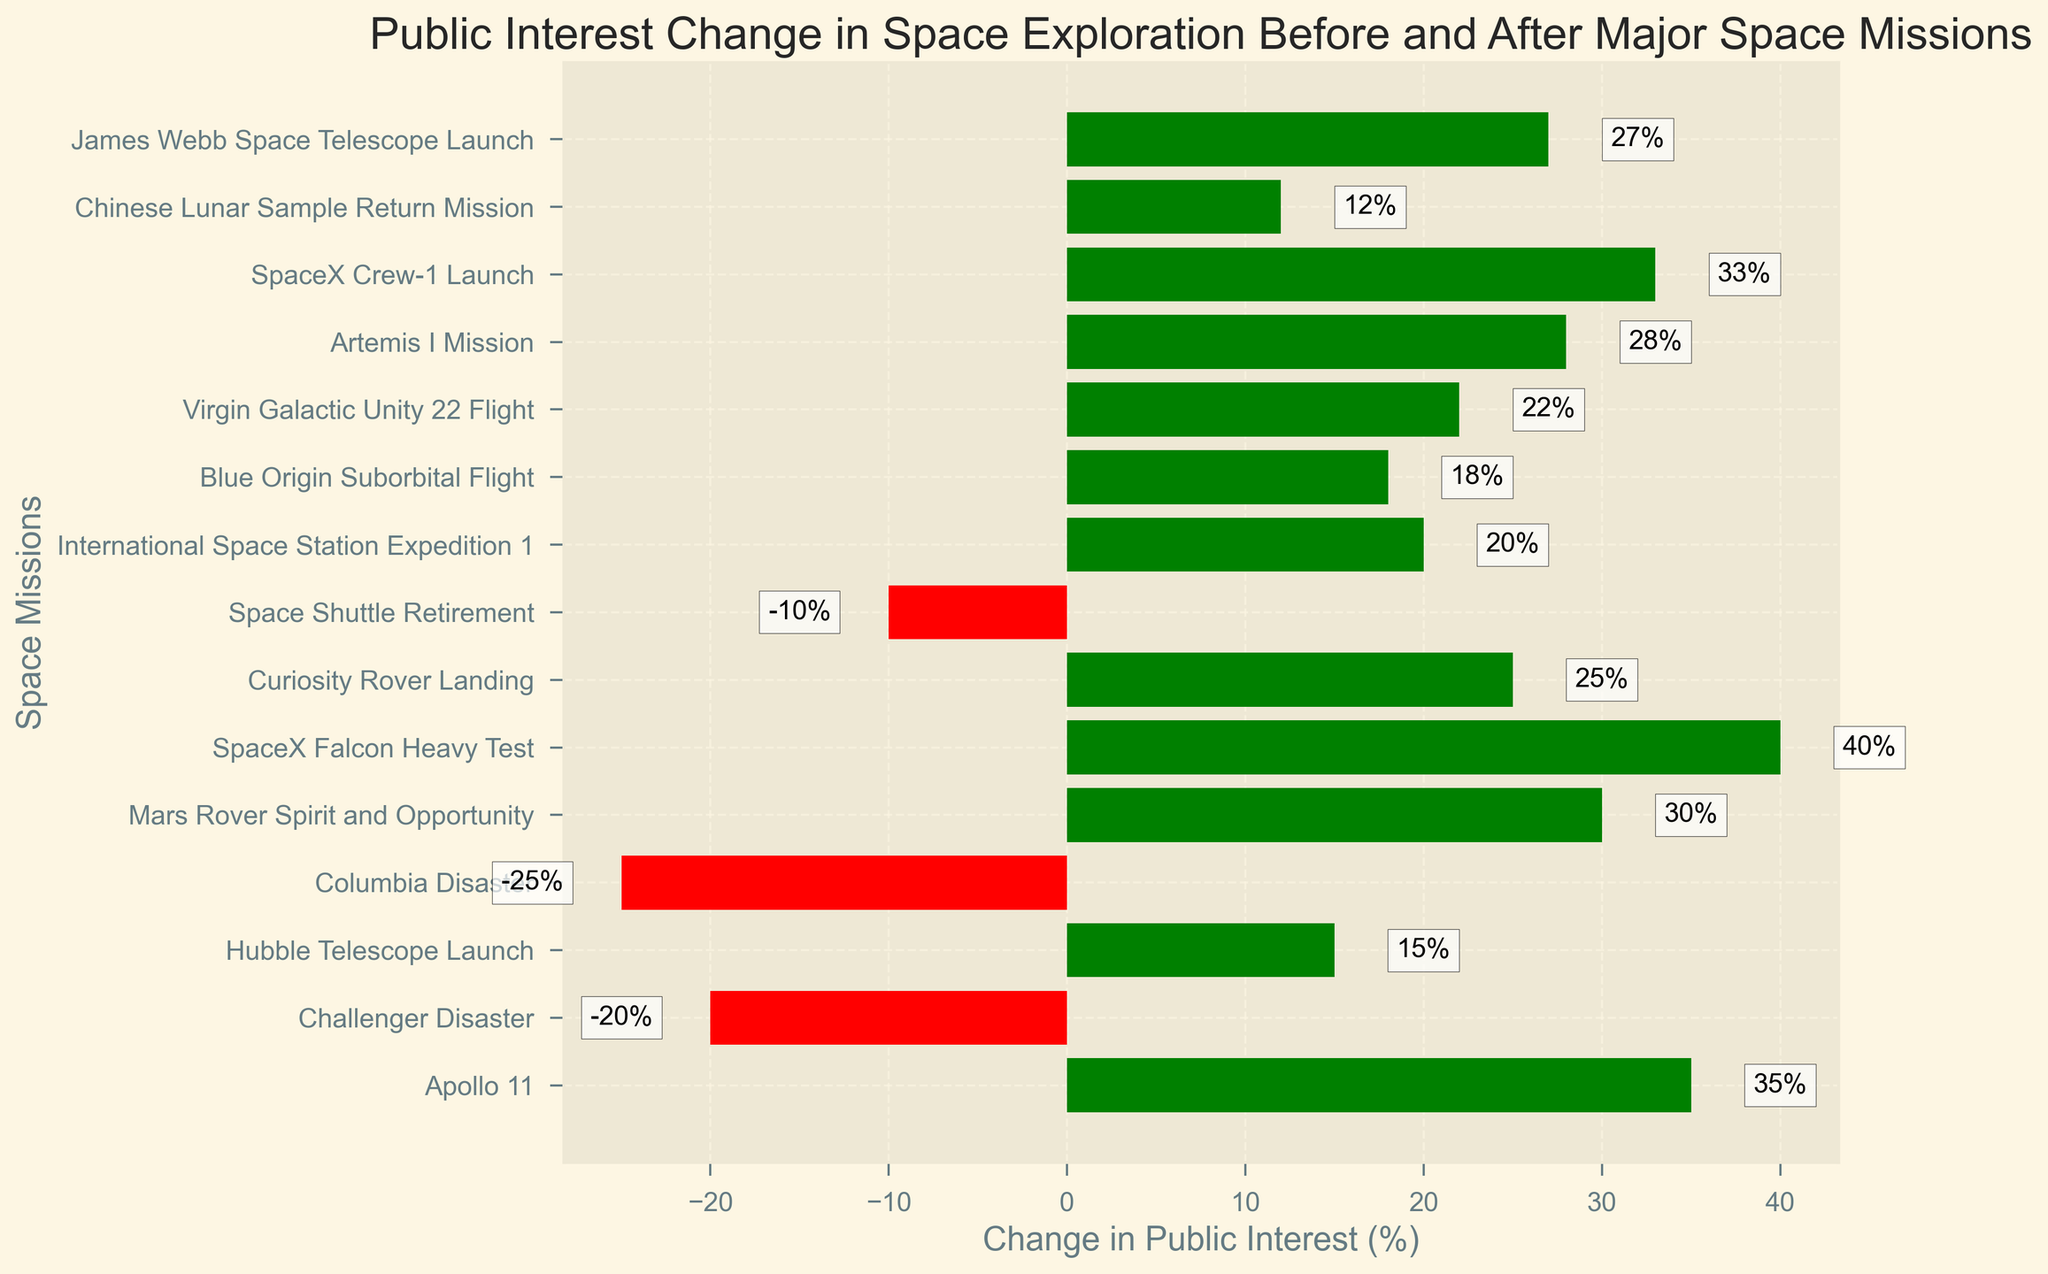Which space mission saw the greatest increase in public interest? Look at the mission with the longest green bar, which represents the greatest positive change in public interest.
Answer: SpaceX Falcon Heavy Test Which space mission saw the greatest decrease in public interest? Look at the mission with the longest red bar, which represents the greatest negative change in public interest.
Answer: Columbia Disaster How many missions resulted in a negative change in public interest? Count the number of bars that are red, indicating a negative change.
Answer: 3 What is the total change in public interest for all the missions combined? Sum the values of all the bars (positive and negative) to get the total change in public interest.
Answer: 270 Compare the public interest change in the Apollo 11 mission to the SpaceX Crew-1 Launch. Which had a higher increase? Compare the lengths of the green bars for Apollo 11 and SpaceX Crew-1 Launch. Apollo 11 is 35% and SpaceX Crew-1 Launch is 33%.
Answer: Apollo 11 What is the average change in public interest among the missions listed? Add up all the changes and divide by the number of missions to find the average. Total change is 270, and there are 15 missions, so the average is 270 / 15.
Answer: 18 How does the public interest change for the Challenger Disaster compare to the Space Shuttle Retirement? Compare the lengths of the red bars for both missions. Challenger Disaster is -20% and Space Shuttle Retirement is -10%.
Answer: Challenger Disaster is lower Which mission had a higher public interest change, the Curiosity Rover Landing or the Blue Origin Suborbital Flight? Compare the lengths of their green bars. Curiosity Rover Landing is 25% and Blue Origin Suborbital Flight is 18%.
Answer: Curiosity Rover Landing What is the median change in public interest for the listed missions? Arrange the changes in numerical order and find the middle value. The ordered changes are: -25, -20, -10, 12, 15, 18, 20, 22, 25, 27, 28, 30, 33, 35, 40. The median value is (20+22)/2.
Answer: 21 Which missions have a change in public interest less than zero? Identify the missions with red bars: Challenger Disaster, Columbia Disaster, Space Shuttle Retirement.
Answer: Challenger Disaster, Columbia Disaster, Space Shuttle Retirement 